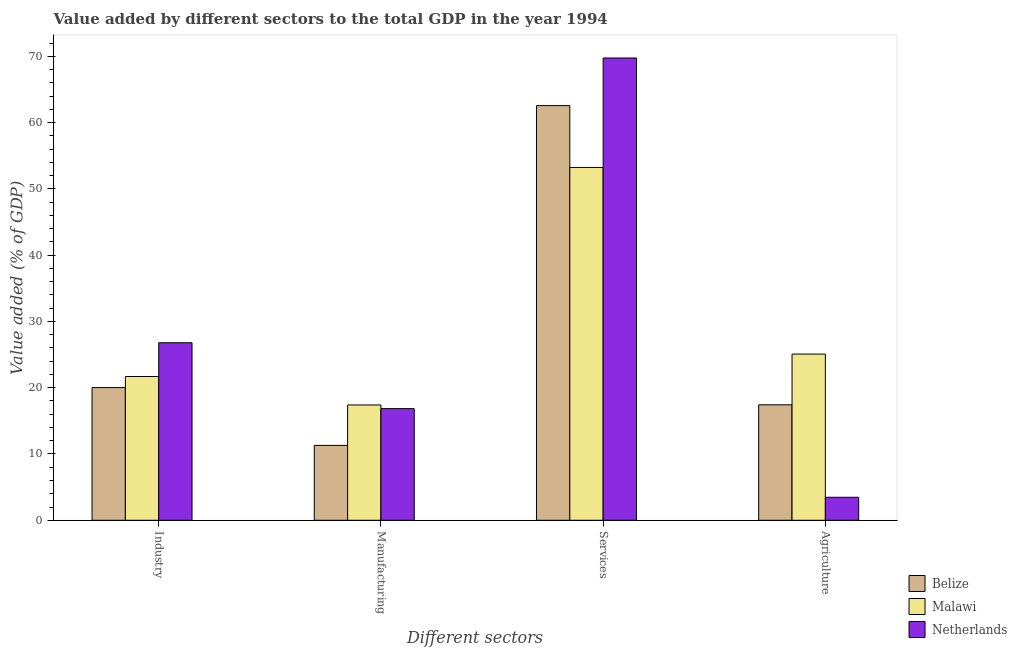How many different coloured bars are there?
Offer a very short reply. 3. Are the number of bars on each tick of the X-axis equal?
Give a very brief answer. Yes. How many bars are there on the 3rd tick from the left?
Make the answer very short. 3. What is the label of the 2nd group of bars from the left?
Give a very brief answer. Manufacturing. What is the value added by manufacturing sector in Malawi?
Your answer should be very brief. 17.39. Across all countries, what is the maximum value added by agricultural sector?
Your answer should be very brief. 25.08. Across all countries, what is the minimum value added by manufacturing sector?
Offer a terse response. 11.3. In which country was the value added by manufacturing sector maximum?
Keep it short and to the point. Malawi. In which country was the value added by services sector minimum?
Provide a short and direct response. Malawi. What is the total value added by manufacturing sector in the graph?
Provide a short and direct response. 45.54. What is the difference between the value added by agricultural sector in Malawi and that in Netherlands?
Your response must be concise. 21.61. What is the difference between the value added by services sector in Netherlands and the value added by manufacturing sector in Malawi?
Ensure brevity in your answer.  52.35. What is the average value added by services sector per country?
Your answer should be compact. 61.85. What is the difference between the value added by services sector and value added by manufacturing sector in Netherlands?
Offer a terse response. 52.9. What is the ratio of the value added by industrial sector in Belize to that in Malawi?
Offer a terse response. 0.92. What is the difference between the highest and the second highest value added by industrial sector?
Provide a succinct answer. 5.09. What is the difference between the highest and the lowest value added by services sector?
Give a very brief answer. 16.51. Is the sum of the value added by services sector in Malawi and Belize greater than the maximum value added by manufacturing sector across all countries?
Offer a terse response. Yes. What does the 3rd bar from the left in Services represents?
Your answer should be very brief. Netherlands. What does the 2nd bar from the right in Agriculture represents?
Provide a succinct answer. Malawi. Are all the bars in the graph horizontal?
Your answer should be very brief. No. How many countries are there in the graph?
Offer a very short reply. 3. What is the difference between two consecutive major ticks on the Y-axis?
Make the answer very short. 10. Where does the legend appear in the graph?
Ensure brevity in your answer.  Bottom right. How many legend labels are there?
Provide a short and direct response. 3. What is the title of the graph?
Your response must be concise. Value added by different sectors to the total GDP in the year 1994. Does "Liberia" appear as one of the legend labels in the graph?
Give a very brief answer. No. What is the label or title of the X-axis?
Your response must be concise. Different sectors. What is the label or title of the Y-axis?
Give a very brief answer. Value added (% of GDP). What is the Value added (% of GDP) in Belize in Industry?
Offer a very short reply. 20.02. What is the Value added (% of GDP) of Malawi in Industry?
Offer a very short reply. 21.69. What is the Value added (% of GDP) of Netherlands in Industry?
Offer a terse response. 26.78. What is the Value added (% of GDP) of Belize in Manufacturing?
Offer a terse response. 11.3. What is the Value added (% of GDP) in Malawi in Manufacturing?
Your answer should be very brief. 17.39. What is the Value added (% of GDP) in Netherlands in Manufacturing?
Ensure brevity in your answer.  16.85. What is the Value added (% of GDP) in Belize in Services?
Offer a terse response. 62.56. What is the Value added (% of GDP) in Malawi in Services?
Keep it short and to the point. 53.23. What is the Value added (% of GDP) in Netherlands in Services?
Offer a terse response. 69.75. What is the Value added (% of GDP) of Belize in Agriculture?
Make the answer very short. 17.42. What is the Value added (% of GDP) of Malawi in Agriculture?
Keep it short and to the point. 25.08. What is the Value added (% of GDP) in Netherlands in Agriculture?
Provide a short and direct response. 3.47. Across all Different sectors, what is the maximum Value added (% of GDP) of Belize?
Provide a succinct answer. 62.56. Across all Different sectors, what is the maximum Value added (% of GDP) in Malawi?
Give a very brief answer. 53.23. Across all Different sectors, what is the maximum Value added (% of GDP) in Netherlands?
Give a very brief answer. 69.75. Across all Different sectors, what is the minimum Value added (% of GDP) in Belize?
Offer a terse response. 11.3. Across all Different sectors, what is the minimum Value added (% of GDP) of Malawi?
Your response must be concise. 17.39. Across all Different sectors, what is the minimum Value added (% of GDP) in Netherlands?
Give a very brief answer. 3.47. What is the total Value added (% of GDP) of Belize in the graph?
Your answer should be compact. 111.3. What is the total Value added (% of GDP) in Malawi in the graph?
Make the answer very short. 117.39. What is the total Value added (% of GDP) in Netherlands in the graph?
Offer a very short reply. 116.85. What is the difference between the Value added (% of GDP) in Belize in Industry and that in Manufacturing?
Give a very brief answer. 8.72. What is the difference between the Value added (% of GDP) in Malawi in Industry and that in Manufacturing?
Keep it short and to the point. 4.3. What is the difference between the Value added (% of GDP) in Netherlands in Industry and that in Manufacturing?
Ensure brevity in your answer.  9.94. What is the difference between the Value added (% of GDP) in Belize in Industry and that in Services?
Offer a terse response. -42.55. What is the difference between the Value added (% of GDP) in Malawi in Industry and that in Services?
Your answer should be compact. -31.54. What is the difference between the Value added (% of GDP) of Netherlands in Industry and that in Services?
Your response must be concise. -42.96. What is the difference between the Value added (% of GDP) in Belize in Industry and that in Agriculture?
Your answer should be compact. 2.6. What is the difference between the Value added (% of GDP) in Malawi in Industry and that in Agriculture?
Ensure brevity in your answer.  -3.39. What is the difference between the Value added (% of GDP) of Netherlands in Industry and that in Agriculture?
Provide a short and direct response. 23.31. What is the difference between the Value added (% of GDP) in Belize in Manufacturing and that in Services?
Your response must be concise. -51.27. What is the difference between the Value added (% of GDP) in Malawi in Manufacturing and that in Services?
Ensure brevity in your answer.  -35.84. What is the difference between the Value added (% of GDP) in Netherlands in Manufacturing and that in Services?
Your answer should be very brief. -52.9. What is the difference between the Value added (% of GDP) of Belize in Manufacturing and that in Agriculture?
Offer a very short reply. -6.12. What is the difference between the Value added (% of GDP) of Malawi in Manufacturing and that in Agriculture?
Make the answer very short. -7.68. What is the difference between the Value added (% of GDP) in Netherlands in Manufacturing and that in Agriculture?
Your answer should be compact. 13.38. What is the difference between the Value added (% of GDP) of Belize in Services and that in Agriculture?
Give a very brief answer. 45.14. What is the difference between the Value added (% of GDP) in Malawi in Services and that in Agriculture?
Your answer should be compact. 28.16. What is the difference between the Value added (% of GDP) in Netherlands in Services and that in Agriculture?
Give a very brief answer. 66.28. What is the difference between the Value added (% of GDP) in Belize in Industry and the Value added (% of GDP) in Malawi in Manufacturing?
Your answer should be compact. 2.62. What is the difference between the Value added (% of GDP) of Belize in Industry and the Value added (% of GDP) of Netherlands in Manufacturing?
Make the answer very short. 3.17. What is the difference between the Value added (% of GDP) in Malawi in Industry and the Value added (% of GDP) in Netherlands in Manufacturing?
Your answer should be compact. 4.85. What is the difference between the Value added (% of GDP) of Belize in Industry and the Value added (% of GDP) of Malawi in Services?
Make the answer very short. -33.22. What is the difference between the Value added (% of GDP) of Belize in Industry and the Value added (% of GDP) of Netherlands in Services?
Your answer should be very brief. -49.73. What is the difference between the Value added (% of GDP) in Malawi in Industry and the Value added (% of GDP) in Netherlands in Services?
Provide a succinct answer. -48.06. What is the difference between the Value added (% of GDP) of Belize in Industry and the Value added (% of GDP) of Malawi in Agriculture?
Your answer should be very brief. -5.06. What is the difference between the Value added (% of GDP) of Belize in Industry and the Value added (% of GDP) of Netherlands in Agriculture?
Offer a very short reply. 16.55. What is the difference between the Value added (% of GDP) in Malawi in Industry and the Value added (% of GDP) in Netherlands in Agriculture?
Your answer should be very brief. 18.22. What is the difference between the Value added (% of GDP) in Belize in Manufacturing and the Value added (% of GDP) in Malawi in Services?
Provide a succinct answer. -41.94. What is the difference between the Value added (% of GDP) of Belize in Manufacturing and the Value added (% of GDP) of Netherlands in Services?
Ensure brevity in your answer.  -58.45. What is the difference between the Value added (% of GDP) in Malawi in Manufacturing and the Value added (% of GDP) in Netherlands in Services?
Provide a succinct answer. -52.35. What is the difference between the Value added (% of GDP) of Belize in Manufacturing and the Value added (% of GDP) of Malawi in Agriculture?
Provide a short and direct response. -13.78. What is the difference between the Value added (% of GDP) in Belize in Manufacturing and the Value added (% of GDP) in Netherlands in Agriculture?
Your answer should be compact. 7.83. What is the difference between the Value added (% of GDP) of Malawi in Manufacturing and the Value added (% of GDP) of Netherlands in Agriculture?
Keep it short and to the point. 13.92. What is the difference between the Value added (% of GDP) of Belize in Services and the Value added (% of GDP) of Malawi in Agriculture?
Provide a succinct answer. 37.49. What is the difference between the Value added (% of GDP) in Belize in Services and the Value added (% of GDP) in Netherlands in Agriculture?
Provide a short and direct response. 59.1. What is the difference between the Value added (% of GDP) in Malawi in Services and the Value added (% of GDP) in Netherlands in Agriculture?
Give a very brief answer. 49.76. What is the average Value added (% of GDP) in Belize per Different sectors?
Make the answer very short. 27.82. What is the average Value added (% of GDP) of Malawi per Different sectors?
Your answer should be compact. 29.35. What is the average Value added (% of GDP) of Netherlands per Different sectors?
Give a very brief answer. 29.21. What is the difference between the Value added (% of GDP) in Belize and Value added (% of GDP) in Malawi in Industry?
Your answer should be very brief. -1.67. What is the difference between the Value added (% of GDP) of Belize and Value added (% of GDP) of Netherlands in Industry?
Ensure brevity in your answer.  -6.77. What is the difference between the Value added (% of GDP) of Malawi and Value added (% of GDP) of Netherlands in Industry?
Your response must be concise. -5.09. What is the difference between the Value added (% of GDP) of Belize and Value added (% of GDP) of Malawi in Manufacturing?
Your response must be concise. -6.1. What is the difference between the Value added (% of GDP) of Belize and Value added (% of GDP) of Netherlands in Manufacturing?
Give a very brief answer. -5.55. What is the difference between the Value added (% of GDP) of Malawi and Value added (% of GDP) of Netherlands in Manufacturing?
Provide a succinct answer. 0.55. What is the difference between the Value added (% of GDP) in Belize and Value added (% of GDP) in Malawi in Services?
Your response must be concise. 9.33. What is the difference between the Value added (% of GDP) of Belize and Value added (% of GDP) of Netherlands in Services?
Provide a short and direct response. -7.18. What is the difference between the Value added (% of GDP) in Malawi and Value added (% of GDP) in Netherlands in Services?
Ensure brevity in your answer.  -16.51. What is the difference between the Value added (% of GDP) in Belize and Value added (% of GDP) in Malawi in Agriculture?
Provide a short and direct response. -7.66. What is the difference between the Value added (% of GDP) in Belize and Value added (% of GDP) in Netherlands in Agriculture?
Provide a succinct answer. 13.95. What is the difference between the Value added (% of GDP) in Malawi and Value added (% of GDP) in Netherlands in Agriculture?
Keep it short and to the point. 21.61. What is the ratio of the Value added (% of GDP) in Belize in Industry to that in Manufacturing?
Ensure brevity in your answer.  1.77. What is the ratio of the Value added (% of GDP) of Malawi in Industry to that in Manufacturing?
Keep it short and to the point. 1.25. What is the ratio of the Value added (% of GDP) of Netherlands in Industry to that in Manufacturing?
Offer a very short reply. 1.59. What is the ratio of the Value added (% of GDP) in Belize in Industry to that in Services?
Your response must be concise. 0.32. What is the ratio of the Value added (% of GDP) in Malawi in Industry to that in Services?
Your answer should be very brief. 0.41. What is the ratio of the Value added (% of GDP) of Netherlands in Industry to that in Services?
Provide a short and direct response. 0.38. What is the ratio of the Value added (% of GDP) of Belize in Industry to that in Agriculture?
Your answer should be very brief. 1.15. What is the ratio of the Value added (% of GDP) in Malawi in Industry to that in Agriculture?
Give a very brief answer. 0.86. What is the ratio of the Value added (% of GDP) in Netherlands in Industry to that in Agriculture?
Give a very brief answer. 7.72. What is the ratio of the Value added (% of GDP) of Belize in Manufacturing to that in Services?
Your answer should be very brief. 0.18. What is the ratio of the Value added (% of GDP) of Malawi in Manufacturing to that in Services?
Your response must be concise. 0.33. What is the ratio of the Value added (% of GDP) of Netherlands in Manufacturing to that in Services?
Give a very brief answer. 0.24. What is the ratio of the Value added (% of GDP) in Belize in Manufacturing to that in Agriculture?
Provide a short and direct response. 0.65. What is the ratio of the Value added (% of GDP) of Malawi in Manufacturing to that in Agriculture?
Provide a short and direct response. 0.69. What is the ratio of the Value added (% of GDP) of Netherlands in Manufacturing to that in Agriculture?
Provide a short and direct response. 4.86. What is the ratio of the Value added (% of GDP) in Belize in Services to that in Agriculture?
Keep it short and to the point. 3.59. What is the ratio of the Value added (% of GDP) in Malawi in Services to that in Agriculture?
Provide a succinct answer. 2.12. What is the ratio of the Value added (% of GDP) of Netherlands in Services to that in Agriculture?
Make the answer very short. 20.11. What is the difference between the highest and the second highest Value added (% of GDP) in Belize?
Keep it short and to the point. 42.55. What is the difference between the highest and the second highest Value added (% of GDP) of Malawi?
Your response must be concise. 28.16. What is the difference between the highest and the second highest Value added (% of GDP) in Netherlands?
Your answer should be compact. 42.96. What is the difference between the highest and the lowest Value added (% of GDP) in Belize?
Your answer should be very brief. 51.27. What is the difference between the highest and the lowest Value added (% of GDP) in Malawi?
Your response must be concise. 35.84. What is the difference between the highest and the lowest Value added (% of GDP) of Netherlands?
Ensure brevity in your answer.  66.28. 